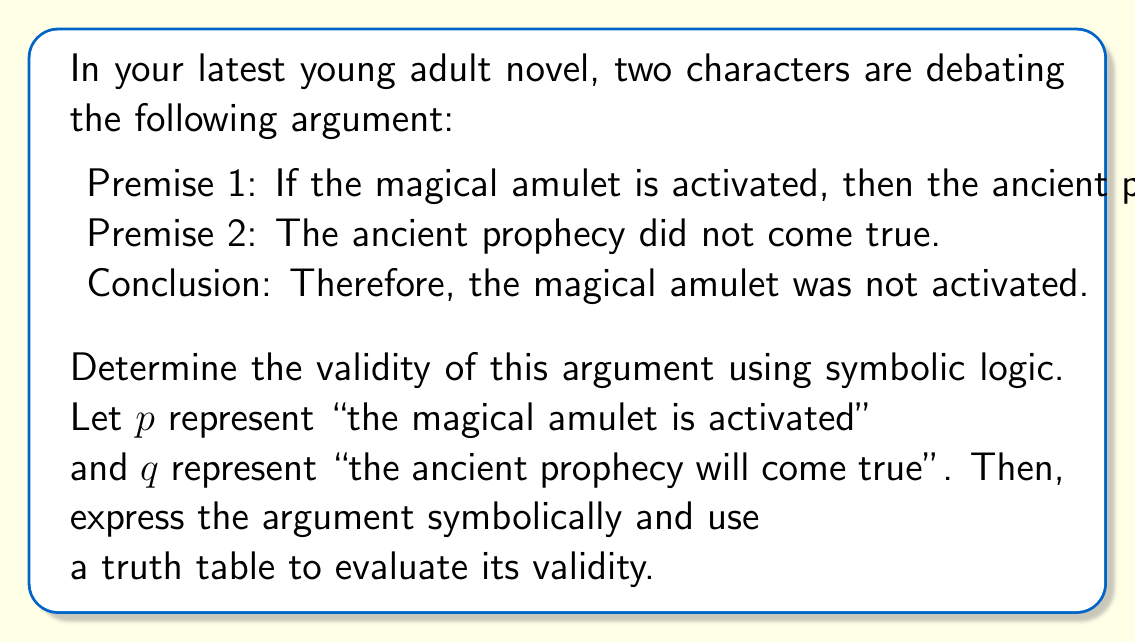Provide a solution to this math problem. To determine the validity of this argument, we'll follow these steps:

1) First, let's express the argument symbolically:
   Premise 1: $p \rightarrow q$
   Premise 2: $\neg q$
   Conclusion: $\therefore \neg p$

   This form of argument is known as Modus Tollens.

2) Now, we'll create a truth table to evaluate all possible combinations:

   $$
   \begin{array}{|c|c|c|c|c|}
   \hline
   p & q & p \rightarrow q & \neg q & \neg p \\
   \hline
   T & T & T & F & F \\
   T & F & F & T & F \\
   F & T & T & F & T \\
   F & F & T & T & T \\
   \hline
   \end{array}
   $$

3) To determine validity, we need to check if there's any row where all premises are true (T) but the conclusion is false (F).

4) The premises are true in the last row:
   - $p \rightarrow q$ is T
   - $\neg q$ is T

5) In this row, we see that the conclusion $\neg p$ is also T.

6) Since there's no row where all premises are true and the conclusion is false, the argument is valid.

This logical structure ensures that if the premises are true, the conclusion must also be true, making it a valid form of argument in your novel's debate.
Answer: Valid 